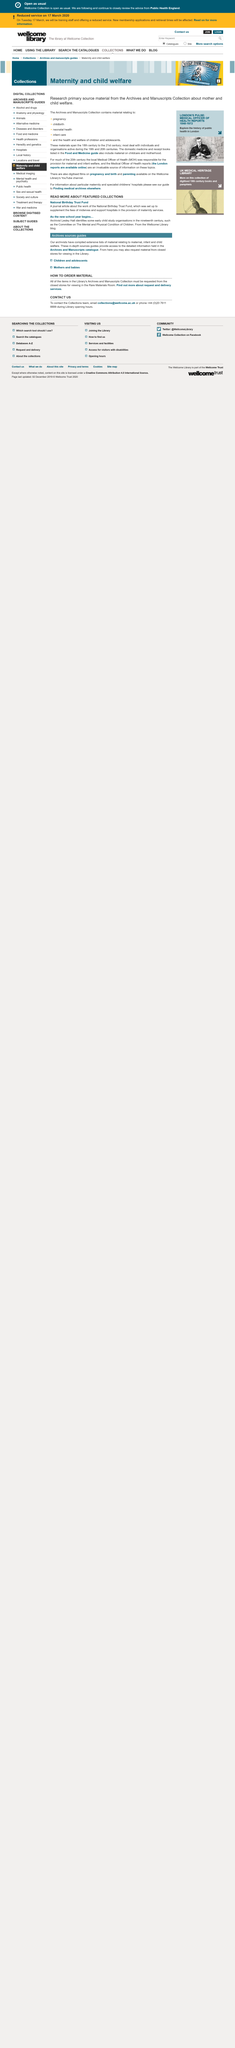Indicate a few pertinent items in this graphic. Lesley Hall is an archivist. There are featured collections, including the national birthday trust fund and as the new school year begins... The National Birthday Trust Fund was established to provide supplementary fees for midwives and support hospitals in the delivery of maternity services. 